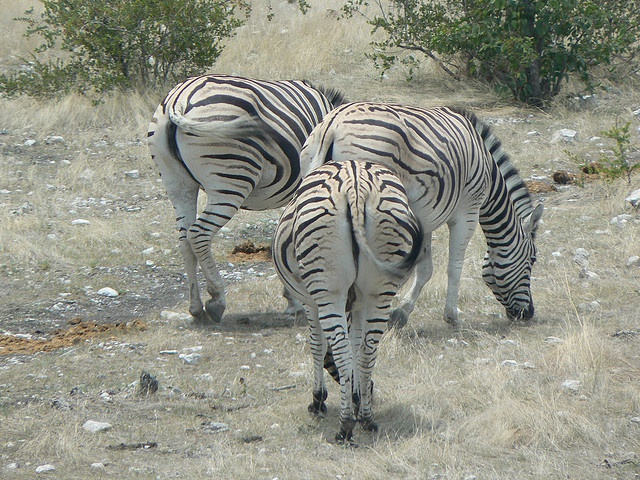Describe the objects in this image and their specific colors. I can see zebra in darkgray, gray, and black tones, zebra in darkgray, gray, black, and beige tones, and zebra in darkgray, gray, black, and beige tones in this image. 